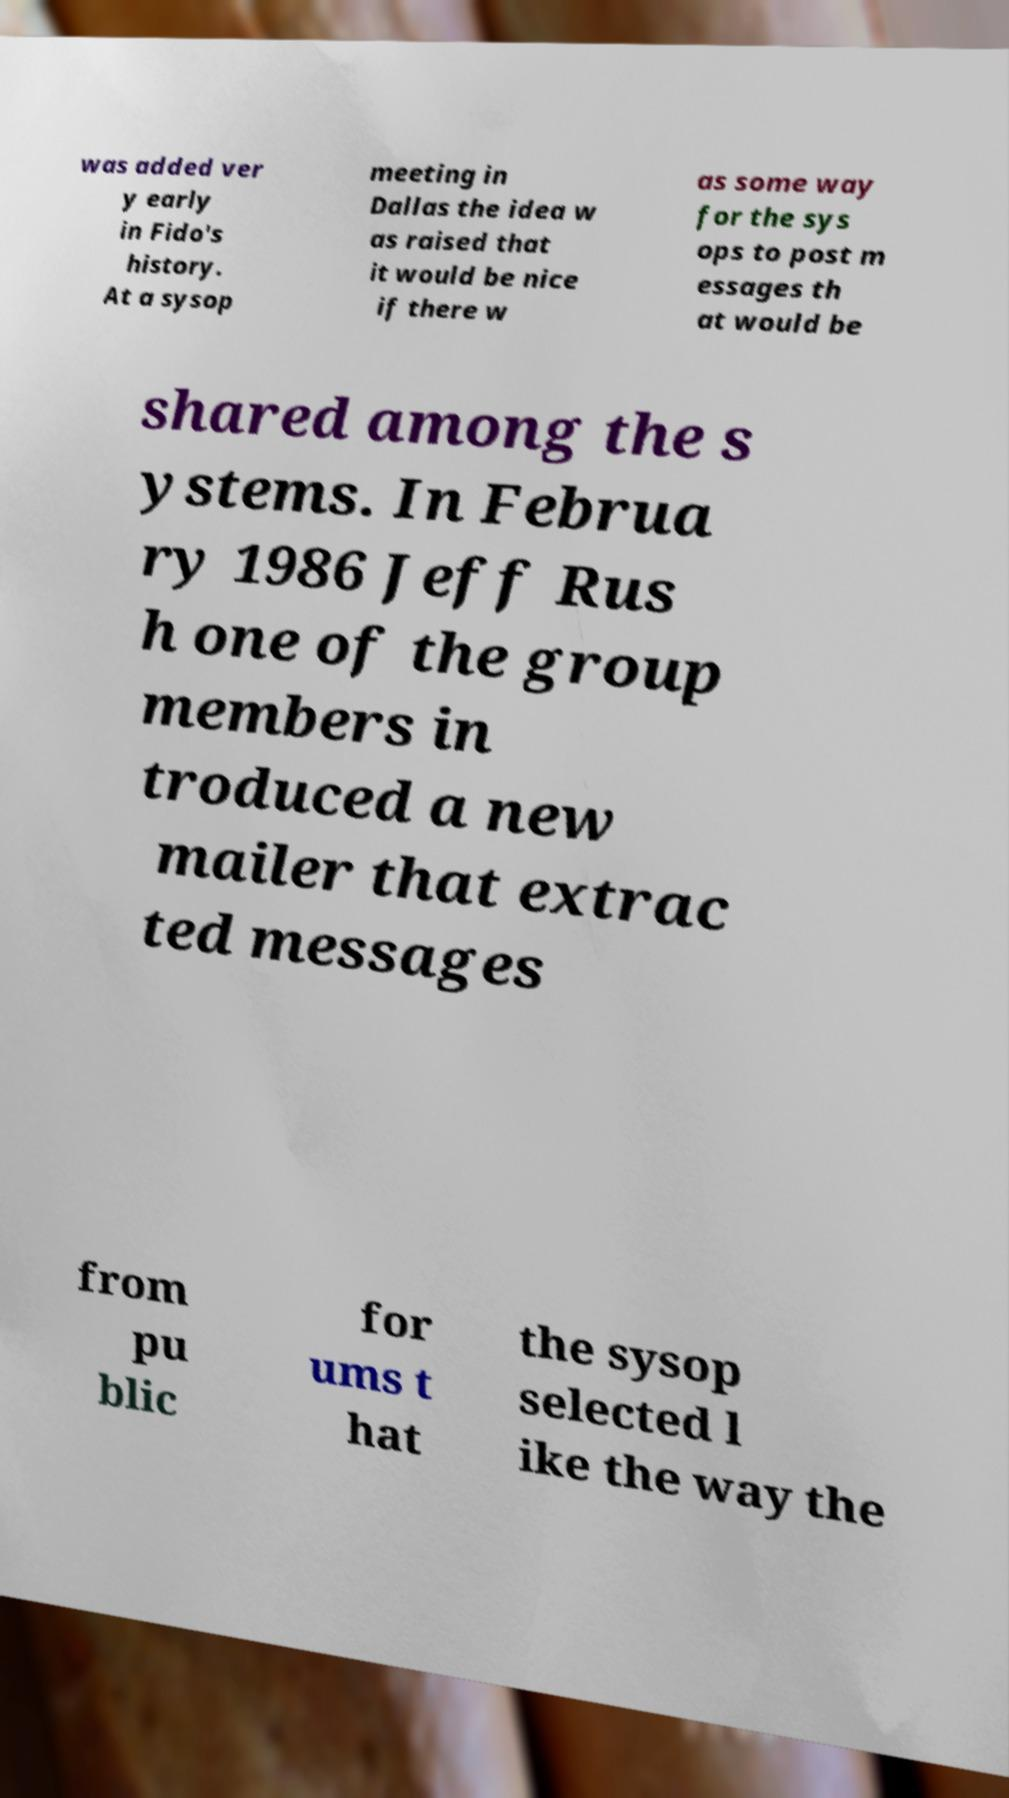For documentation purposes, I need the text within this image transcribed. Could you provide that? was added ver y early in Fido's history. At a sysop meeting in Dallas the idea w as raised that it would be nice if there w as some way for the sys ops to post m essages th at would be shared among the s ystems. In Februa ry 1986 Jeff Rus h one of the group members in troduced a new mailer that extrac ted messages from pu blic for ums t hat the sysop selected l ike the way the 